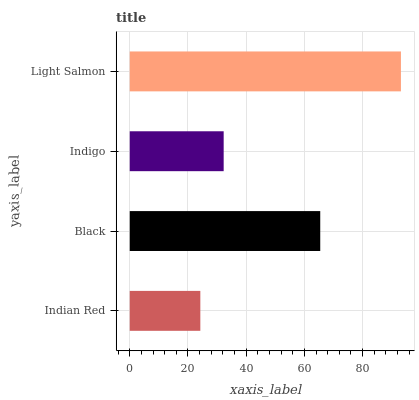Is Indian Red the minimum?
Answer yes or no. Yes. Is Light Salmon the maximum?
Answer yes or no. Yes. Is Black the minimum?
Answer yes or no. No. Is Black the maximum?
Answer yes or no. No. Is Black greater than Indian Red?
Answer yes or no. Yes. Is Indian Red less than Black?
Answer yes or no. Yes. Is Indian Red greater than Black?
Answer yes or no. No. Is Black less than Indian Red?
Answer yes or no. No. Is Black the high median?
Answer yes or no. Yes. Is Indigo the low median?
Answer yes or no. Yes. Is Indian Red the high median?
Answer yes or no. No. Is Indian Red the low median?
Answer yes or no. No. 